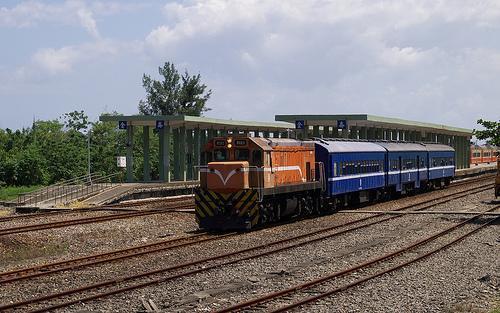How many sets of tracks are there?
Give a very brief answer. 4. 